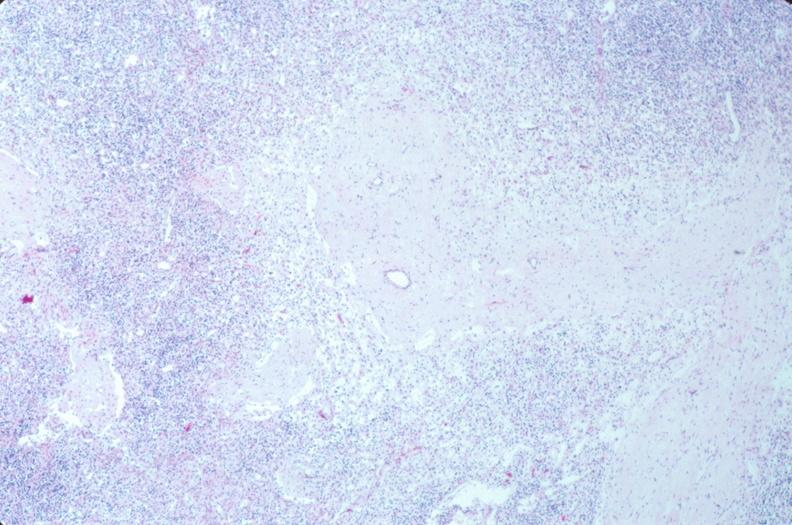does anencephaly and bilateral cleft palate show lymph nodes, nodular sclerosing hodgkins disease?
Answer the question using a single word or phrase. No 